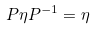Convert formula to latex. <formula><loc_0><loc_0><loc_500><loc_500>P \eta P ^ { - 1 } = \eta</formula> 